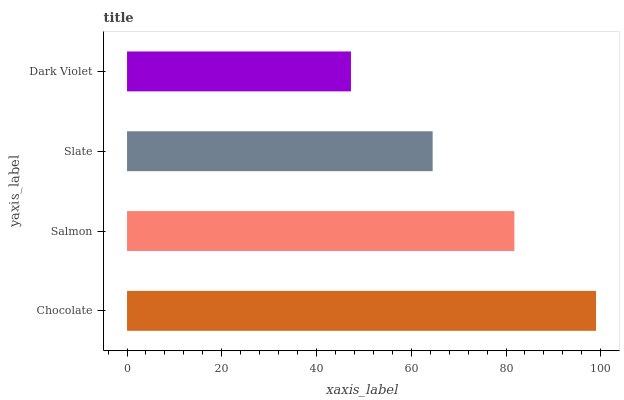Is Dark Violet the minimum?
Answer yes or no. Yes. Is Chocolate the maximum?
Answer yes or no. Yes. Is Salmon the minimum?
Answer yes or no. No. Is Salmon the maximum?
Answer yes or no. No. Is Chocolate greater than Salmon?
Answer yes or no. Yes. Is Salmon less than Chocolate?
Answer yes or no. Yes. Is Salmon greater than Chocolate?
Answer yes or no. No. Is Chocolate less than Salmon?
Answer yes or no. No. Is Salmon the high median?
Answer yes or no. Yes. Is Slate the low median?
Answer yes or no. Yes. Is Slate the high median?
Answer yes or no. No. Is Salmon the low median?
Answer yes or no. No. 